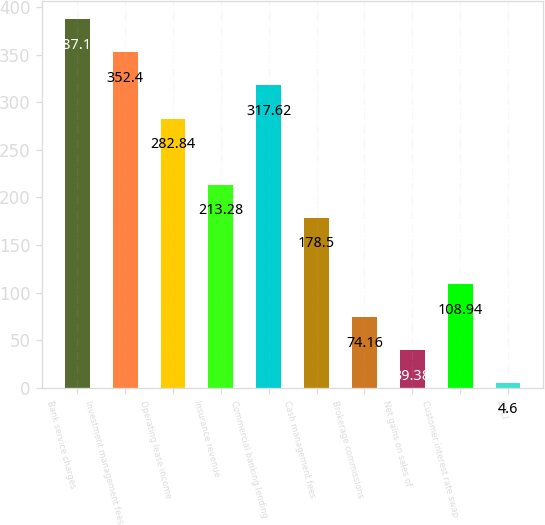Convert chart to OTSL. <chart><loc_0><loc_0><loc_500><loc_500><bar_chart><fcel>Bank service charges<fcel>Investment management fees<fcel>Operating lease income<fcel>Insurance revenue<fcel>Commercial banking lending<fcel>Cash management fees<fcel>Brokerage commissions<fcel>Net gains on sales of<fcel>Customer interest rate swap<fcel>BOLI<nl><fcel>387.18<fcel>352.4<fcel>282.84<fcel>213.28<fcel>317.62<fcel>178.5<fcel>74.16<fcel>39.38<fcel>108.94<fcel>4.6<nl></chart> 